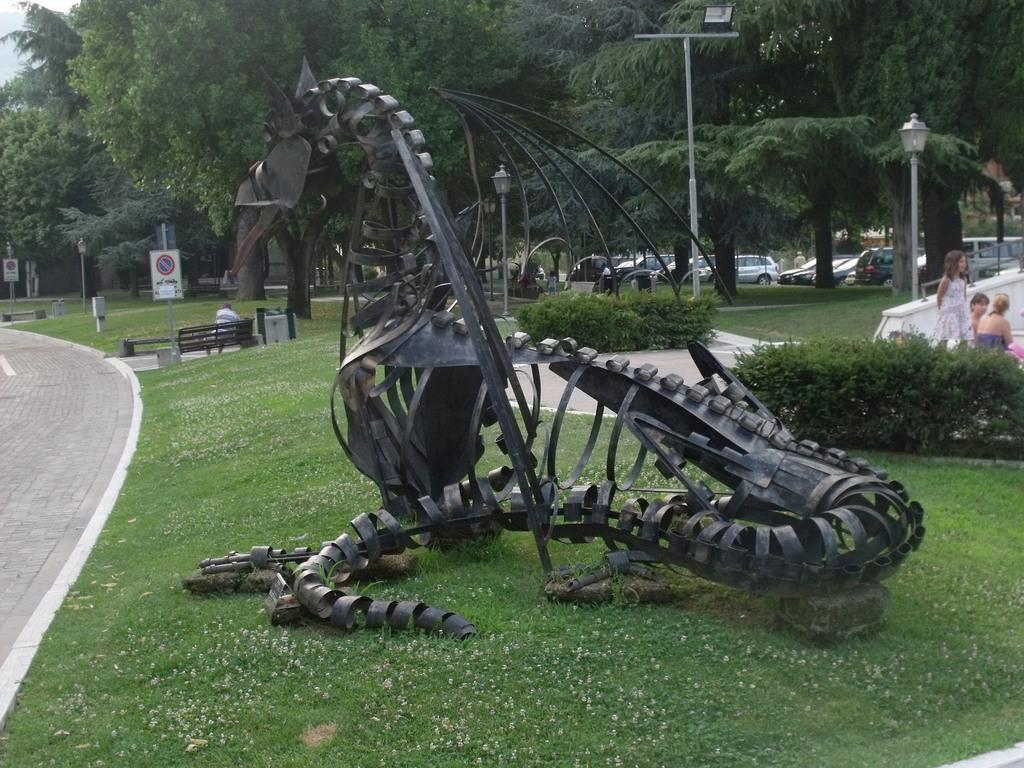Describe this image in one or two sentences. In this image there is a statue on the grassland. Left side there is a path. There is a bench. A person is sitting on the bench. Beside there is a pole having a board attached to it. Right side there are few plants. Behind there are few persons. Behind them there is a wall. There are few street lights on the grassland having few plants and trees. Behind the trees there are few vehicles. 